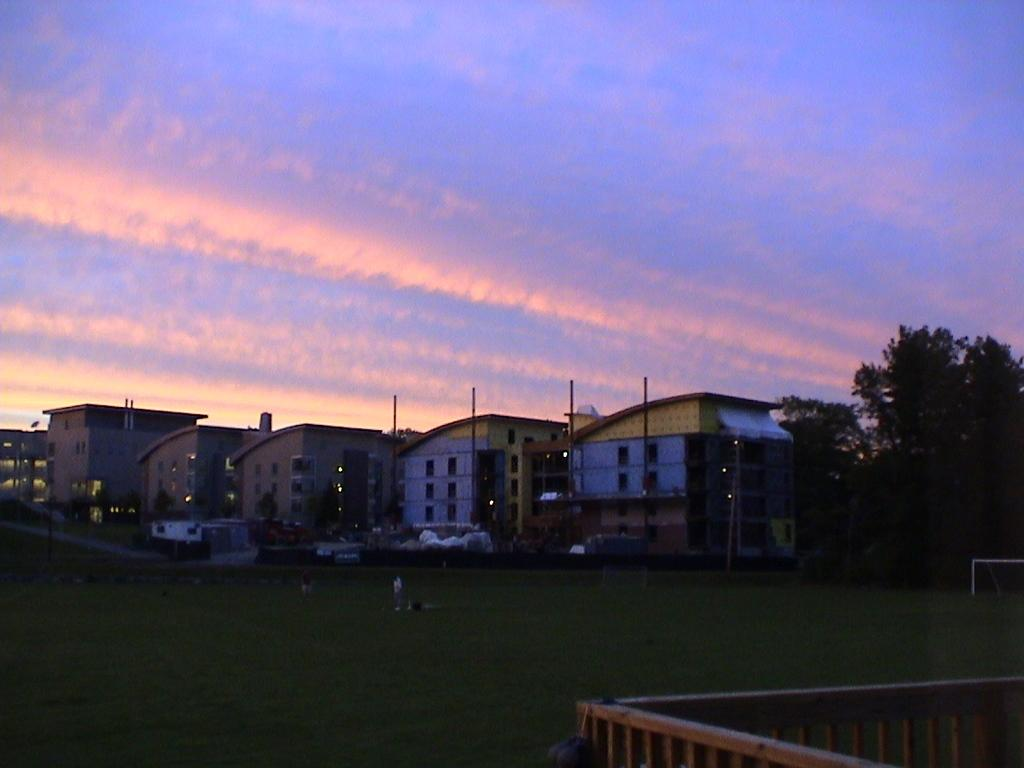What type of vegetation is present in the image? There is green grass and bushes in the image. What type of structures can be seen in the image? There are buildings in the image. What else can be seen in the image besides vegetation and structures? There are poles in the image. What is visible in the background of the image? The sky and trees are visible in the background of the image. How many brothers are sitting on the toadstool in the image? There are no brothers or toadstools present in the image. What is the self-awareness level of the trees in the image? The trees in the image do not have a self-awareness level, as they are inanimate objects. 